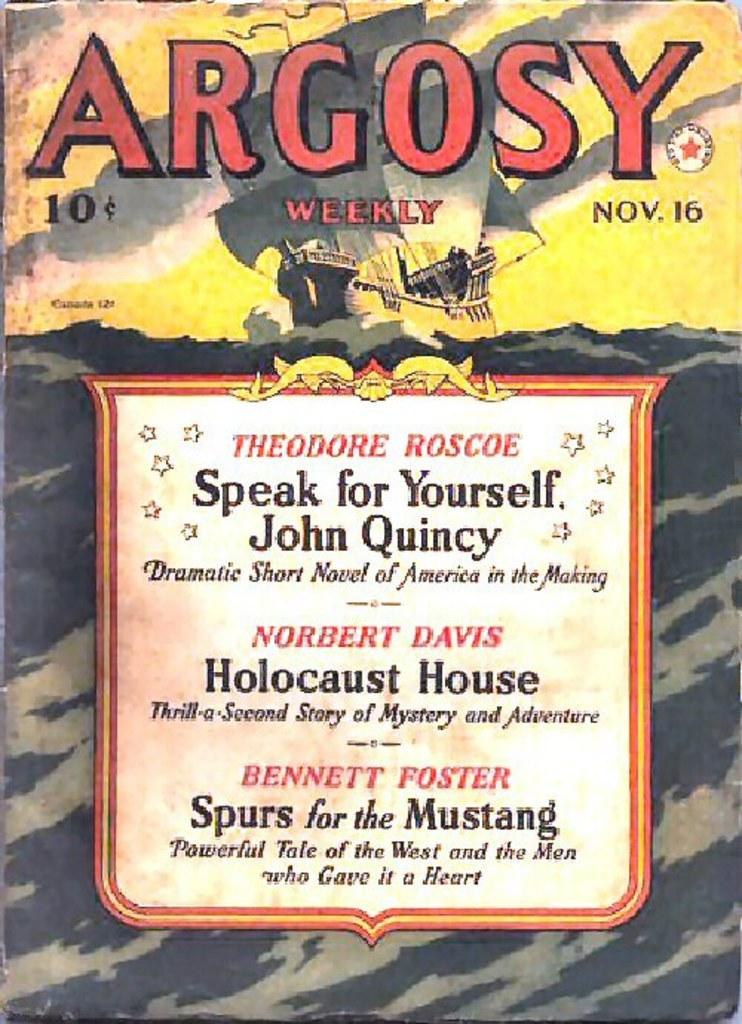<image>
Summarize the visual content of the image. The cover of Argosy featuring Holocaust House and two other stories. 